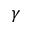Convert formula to latex. <formula><loc_0><loc_0><loc_500><loc_500>\gamma</formula> 